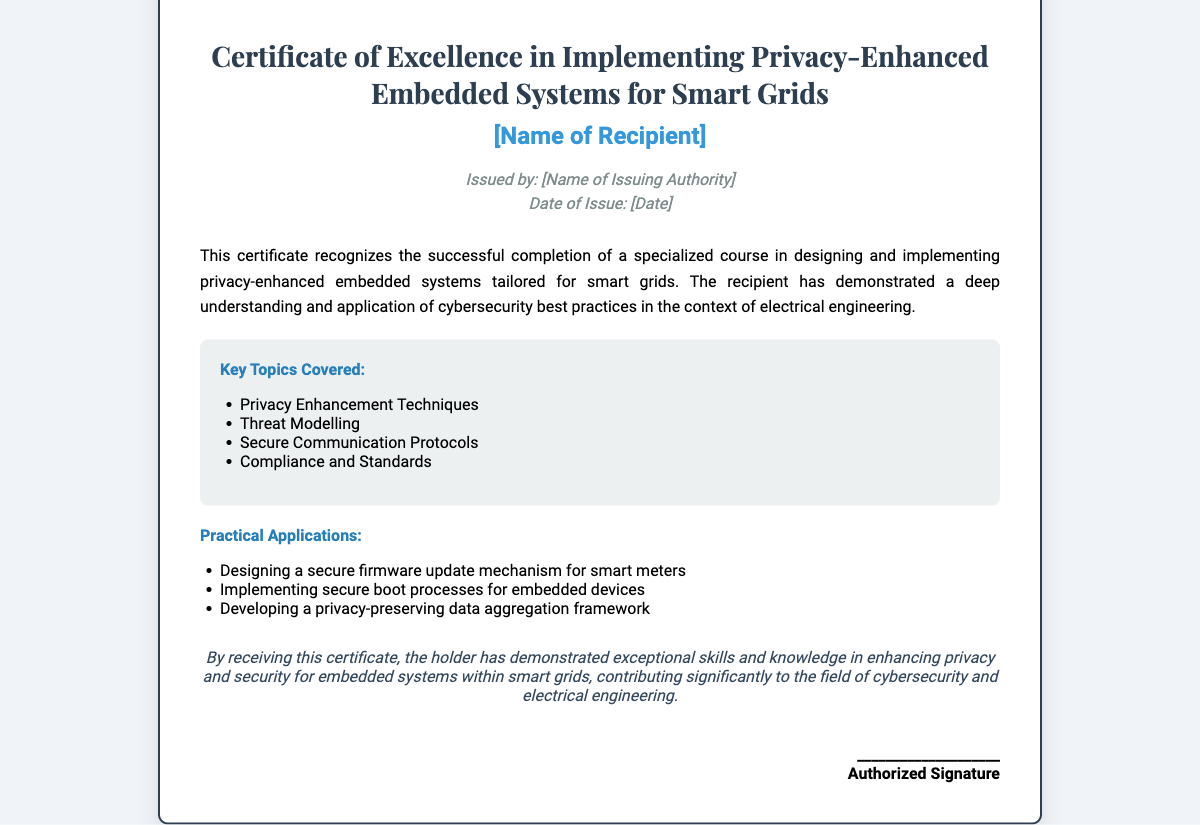What is the title of the certificate? The title of the certificate is clearly stated at the top of the document.
Answer: Certificate of Excellence in Implementing Privacy-Enhanced Embedded Systems for Smart Grids Who is the certificate issued to? The recipient's name is a placeholder that is indicated within the document.
Answer: [Name of Recipient] What is the date of issue? The date of issue is also indicated as a placeholder in the document.
Answer: [Date] What are the key topics covered? The document lists key topics covered under a specific section.
Answer: Privacy Enhancement Techniques, Threat Modelling, Secure Communication Protocols, Compliance and Standards What is one practical application mentioned? The document outlines practical applications under a designated section.
Answer: Designing a secure firmware update mechanism for smart meters What does this certificate demonstrate? The summary states the purpose of the certificate regarding skills and knowledge.
Answer: Exceptional skills and knowledge in enhancing privacy and security Who issued the certificate? The document specifies who provided the certificate with a placeholder.
Answer: [Name of Issuing Authority] How is the background of the certificate designed? The design aspect is described as part of the visual presentation in the document.
Answer: Light background with white certificate What style is used for the recipient's name? The document describes the formatting used for this specific text.
Answer: Bold and colored in blue 